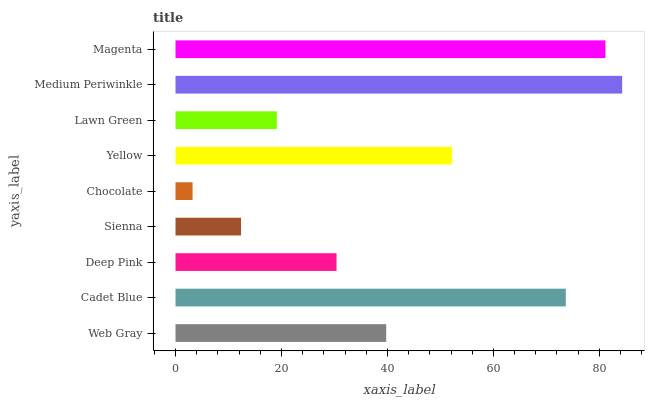Is Chocolate the minimum?
Answer yes or no. Yes. Is Medium Periwinkle the maximum?
Answer yes or no. Yes. Is Cadet Blue the minimum?
Answer yes or no. No. Is Cadet Blue the maximum?
Answer yes or no. No. Is Cadet Blue greater than Web Gray?
Answer yes or no. Yes. Is Web Gray less than Cadet Blue?
Answer yes or no. Yes. Is Web Gray greater than Cadet Blue?
Answer yes or no. No. Is Cadet Blue less than Web Gray?
Answer yes or no. No. Is Web Gray the high median?
Answer yes or no. Yes. Is Web Gray the low median?
Answer yes or no. Yes. Is Sienna the high median?
Answer yes or no. No. Is Lawn Green the low median?
Answer yes or no. No. 